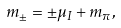<formula> <loc_0><loc_0><loc_500><loc_500>m _ { \pm } = \pm \mu _ { I } + m _ { \pi } ,</formula> 